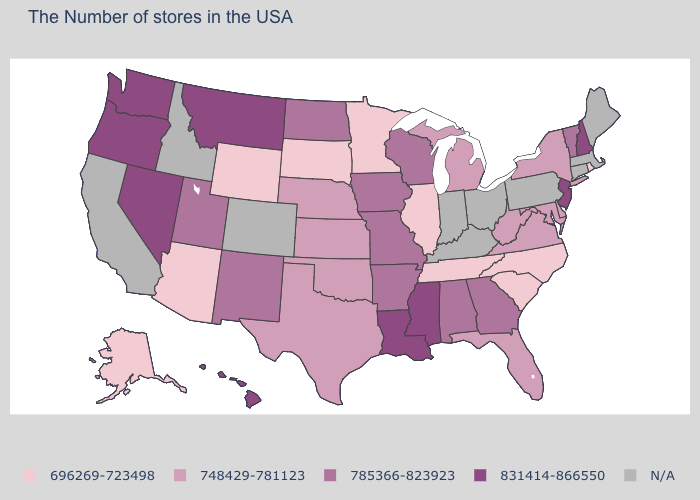Does Washington have the lowest value in the USA?
Answer briefly. No. Which states have the highest value in the USA?
Keep it brief. New Hampshire, New Jersey, Mississippi, Louisiana, Montana, Nevada, Washington, Oregon, Hawaii. Is the legend a continuous bar?
Be succinct. No. What is the value of Oklahoma?
Keep it brief. 748429-781123. Which states have the lowest value in the West?
Short answer required. Wyoming, Arizona, Alaska. Name the states that have a value in the range N/A?
Concise answer only. Maine, Massachusetts, Connecticut, Pennsylvania, Ohio, Kentucky, Indiana, Colorado, Idaho, California. Among the states that border Vermont , which have the lowest value?
Keep it brief. New York. Does Minnesota have the highest value in the USA?
Give a very brief answer. No. Does the map have missing data?
Answer briefly. Yes. Name the states that have a value in the range 696269-723498?
Keep it brief. Rhode Island, North Carolina, South Carolina, Tennessee, Illinois, Minnesota, South Dakota, Wyoming, Arizona, Alaska. Name the states that have a value in the range 831414-866550?
Answer briefly. New Hampshire, New Jersey, Mississippi, Louisiana, Montana, Nevada, Washington, Oregon, Hawaii. 